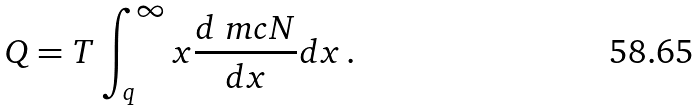Convert formula to latex. <formula><loc_0><loc_0><loc_500><loc_500>Q = T \int _ { q } ^ { \infty } x \frac { d \ m c N } { d x } d x \, .</formula> 